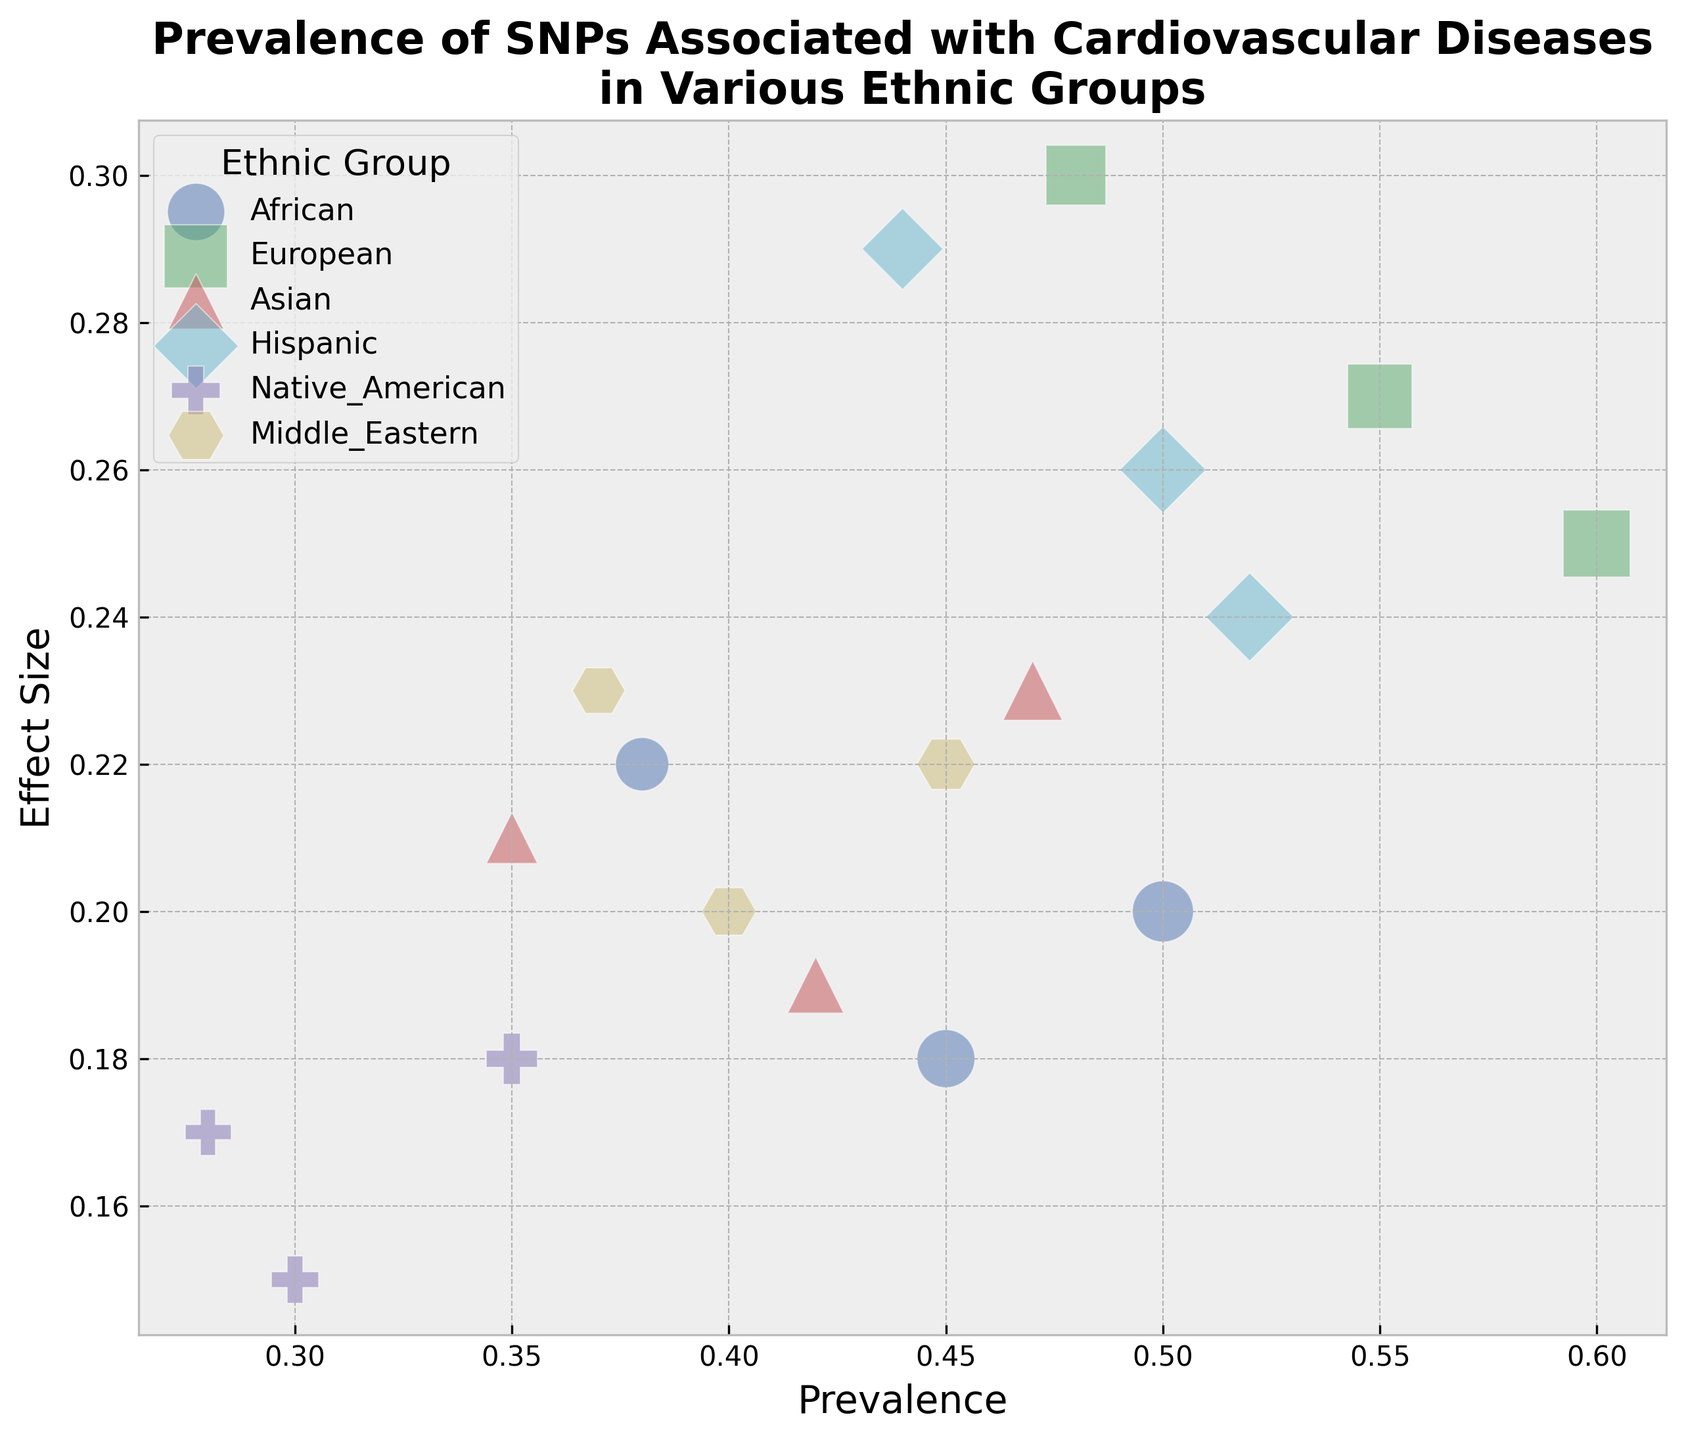Which ethnic group has the highest average prevalence for the SNP rs1333049? We need to compare the prevalence values for rs1333049 across all ethnic groups and find the average prevalence for each. We have: African (0.45), European (0.55), Asian (0.42), Hispanic (0.50), Native American (0.30), and Middle Eastern (0.40). The highest average prevalence among these is 0.55 for the European group.
Answer: European Which ethnic group shows the largest effect size for the SNP rs2383206? We compare the effect sizes of rs2383206 across all ethnic groups. They are African (0.20), European (0.25), Asian (0.23), Hispanic (0.24), Native American (0.18), and Middle Eastern (0.22). The largest effect size is 0.25, which belongs to the European group.
Answer: European Which SNP has the lowest prevalence in the Asian group? We look at the prevalence values of all SNPs in the Asian group. They are rs1333049 (0.42), rs10757274 (0.35), and rs2383206 (0.47). The lowest prevalence among these is 0.35 for rs10757274.
Answer: rs10757274 How does the prevalence of SNP rs10757274 in the Hispanic group compare to that in the African group? We need to compare the prevalence values for rs10757274 in the Hispanic (0.44) and African (0.38) groups. The prevalence is higher in the Hispanic group (0.44) compared to the African group (0.38).
Answer: The prevalence is higher in the Hispanic group Which ethnic group has the smallest bubble for SNP rs1333049? We focus on the SNP rs1333049 and look at the bubble sizes for each ethnic group, determined by prevalence: African (0.45), European (0.55), Asian (0.42), Hispanic (0.50), Native American (0.30), and Middle Eastern (0.40). The smallest bubble corresponds to the Native American group with a prevalence of 0.30.
Answer: Native American What is the effect size range (difference between highest and lowest effect sizes) for SNP rs2383206 across all ethnic groups? We identify the effect sizes for rs2383206 in all ethnic groups: African (0.20), European (0.25), Asian (0.23), Hispanic (0.24), Native American (0.18), and Middle Eastern (0.22). The highest effect size is 0.25 (European) and the lowest is 0.18 (Native American). The range is 0.25 - 0.18 = 0.07.
Answer: 0.07 Between European and Middle Eastern ethnic groups, which one has a higher average effect size across all SNPs? We calculate the average effect size for European and Middle Eastern groups. Europe: (0.27 + 0.30 + 0.25) / 3 = 0.273; Middle Eastern: (0.20 + 0.23 + 0.22) / 3 = 0.217. The European group has a higher average effect size.
Answer: European Which ethnic group and SNP combination has the largest bubble size? The bubble size is proportional to the SNP prevalence. We need to identify the highest prevalence value among all combinations. European with SNP rs2383206 has the highest prevalence (0.60), resulting in the largest bubble.
Answer: European, rs2383206 